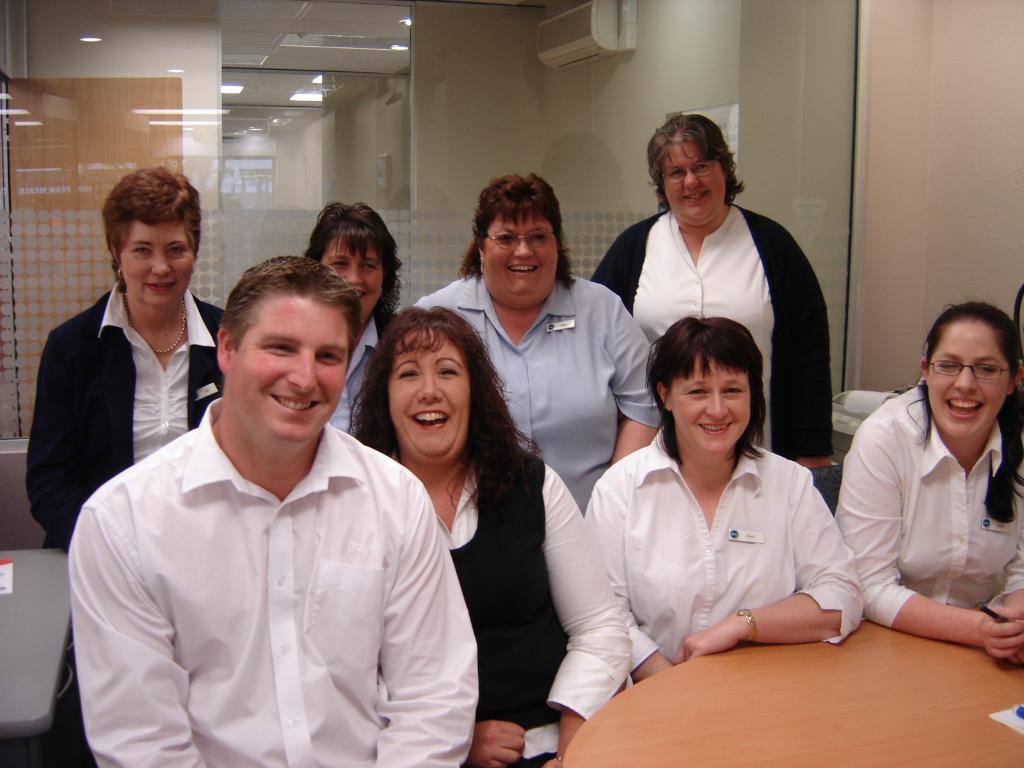In one or two sentences, can you explain what this image depicts? In this image, we can see persons wearing clothes. There is a table in the bottom right of the image. There is an air conditioner at the top of the image. 